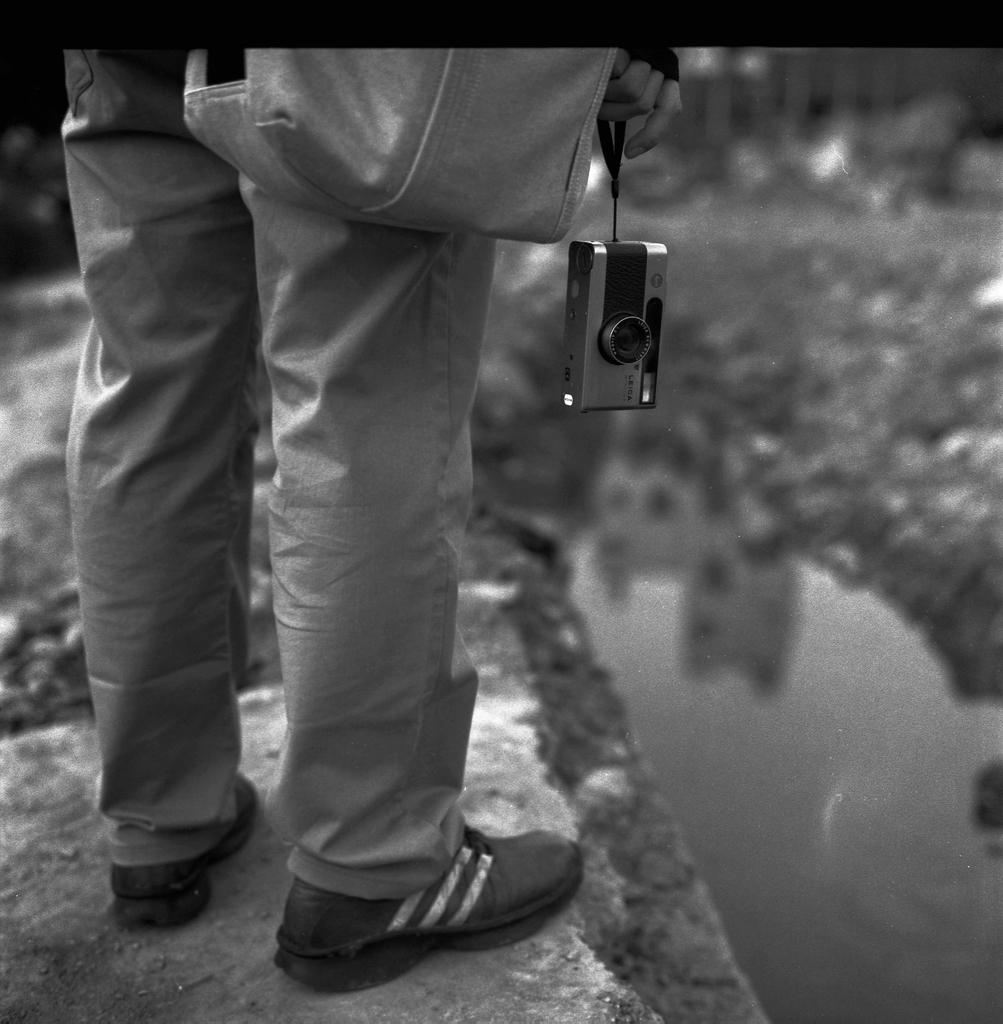What part of a person can be seen in the image? There are legs of a person in the image. What is the person holding in their hand? The person is holding a camera in their hand. What other item is visible in the image? There is a bag visible in the image. What is the setting of the image? There is water in the image, and the background is blurry. What type of vegetable is being used to scoop water in the image? There is no vegetable present in the image, and no one is scooping water. 